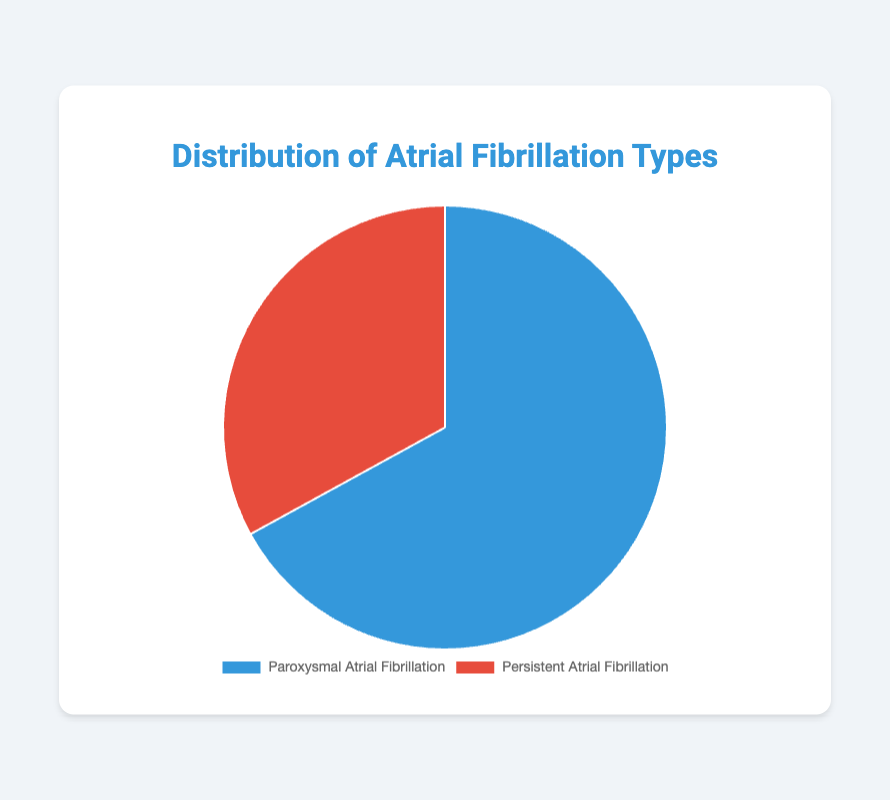Which type of atrial fibrillation is most common in the dataset? The pie chart shows the distribution between paroxysmal and persistent atrial fibrillation. The larger section represents paroxysmal atrial fibrillation.
Answer: Paroxysmal What percentage of patients have persistent atrial fibrillation? The tooltip in the pie chart indicates the percentage for each type. The persistent atrial fibrillation section is indicated as 33%.
Answer: 33% How many patients in total were analyzed to create this chart? Summing the data values for paroxysmal (3,820) and persistent (1,880) atrial fibrillation gives the total number of patients. 3,820 + 1,880 = 5,700
Answer: 5,700 What is the approximate ratio of paroxysmal to persistent atrial fibrillation? The ratio is calculated by dividing the number of patients with paroxysmal atrial fibrillation by those with persistent atrial fibrillation. 3,820 / 1,880 ≈ 2.03
Answer: 2.03:1 Which type of atrial fibrillation has fewer patients? By visually inspecting the pie chart, the smaller section represents persistent atrial fibrillation.
Answer: Persistent How many more patients have paroxysmal atrial fibrillation than persistent atrial fibrillation? Subtract the number of patients with persistent atrial fibrillation from those with paroxysmal atrial fibrillation. 3,820 - 1,880 = 1,940
Answer: 1,940 What is the combined percentage of patients with paroxysmal and persistent atrial fibrillation? The percentages for paroxysmal (67%) and persistent (33%) atrial fibrillation are directly provided on the chart. Summing these gives 67% + 33% = 100%.
Answer: 100% If the number of patients with persistent atrial fibrillation increases by 120, what will be the new percentage for persistent atrial fibrillation? New total patients = 3,820 + (1,880 + 120) = 5740. New persistent percentage = (2,000 / 5,740) * 100 ≈ 34.8%.
Answer: 34.8% 